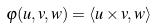Convert formula to latex. <formula><loc_0><loc_0><loc_500><loc_500>\varphi ( u , v , w ) = \langle u \times v , w \rangle</formula> 